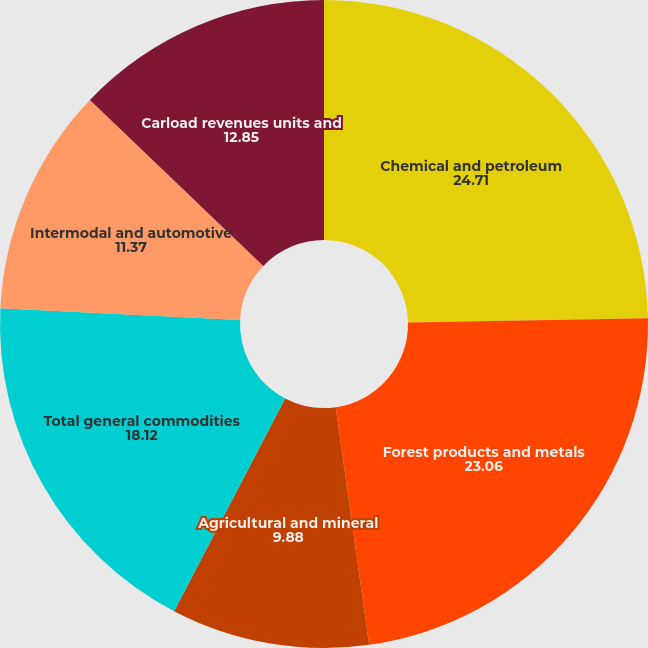Convert chart. <chart><loc_0><loc_0><loc_500><loc_500><pie_chart><fcel>Chemical and petroleum<fcel>Forest products and metals<fcel>Agricultural and mineral<fcel>Total general commodities<fcel>Intermodal and automotive<fcel>Carload revenues units and<nl><fcel>24.71%<fcel>23.06%<fcel>9.88%<fcel>18.12%<fcel>11.37%<fcel>12.85%<nl></chart> 